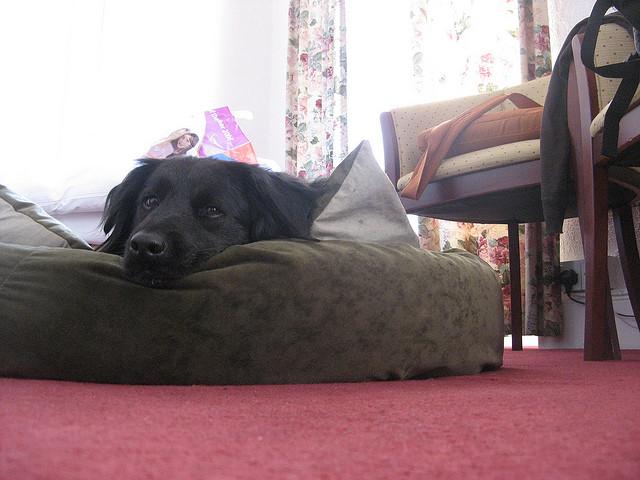What is the dog doing?
Give a very brief answer. Resting. Is the dog tired?
Answer briefly. Yes. What color is the dogs fur?
Write a very short answer. Black. 